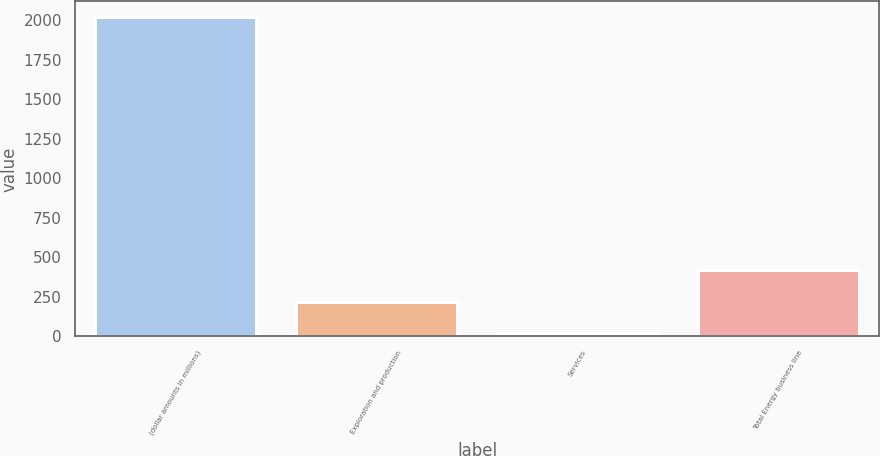Convert chart. <chart><loc_0><loc_0><loc_500><loc_500><bar_chart><fcel>(dollar amounts in millions)<fcel>Exploration and production<fcel>Services<fcel>Total Energy business line<nl><fcel>2018<fcel>218.9<fcel>19<fcel>418.8<nl></chart> 